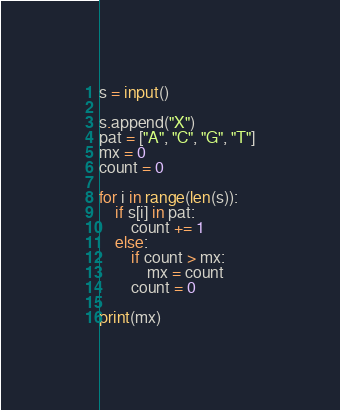Convert code to text. <code><loc_0><loc_0><loc_500><loc_500><_Python_>s = input()

s.append("X")
pat = ["A", "C", "G", "T"]
mx = 0
count = 0

for i in range(len(s)):
    if s[i] in pat:
        count += 1
    else:
        if count > mx:
            mx = count
        count = 0

print(mx)
</code> 